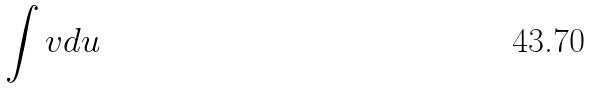Convert formula to latex. <formula><loc_0><loc_0><loc_500><loc_500>\int v d u</formula> 